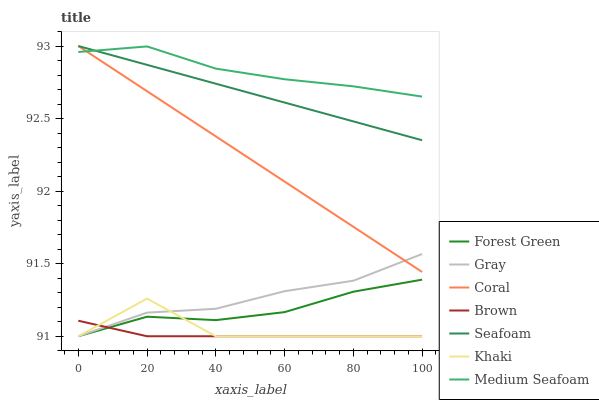Does Brown have the minimum area under the curve?
Answer yes or no. Yes. Does Medium Seafoam have the maximum area under the curve?
Answer yes or no. Yes. Does Khaki have the minimum area under the curve?
Answer yes or no. No. Does Khaki have the maximum area under the curve?
Answer yes or no. No. Is Coral the smoothest?
Answer yes or no. Yes. Is Khaki the roughest?
Answer yes or no. Yes. Is Brown the smoothest?
Answer yes or no. No. Is Brown the roughest?
Answer yes or no. No. Does Gray have the lowest value?
Answer yes or no. Yes. Does Coral have the lowest value?
Answer yes or no. No. Does Seafoam have the highest value?
Answer yes or no. Yes. Does Khaki have the highest value?
Answer yes or no. No. Is Khaki less than Seafoam?
Answer yes or no. Yes. Is Coral greater than Brown?
Answer yes or no. Yes. Does Forest Green intersect Gray?
Answer yes or no. Yes. Is Forest Green less than Gray?
Answer yes or no. No. Is Forest Green greater than Gray?
Answer yes or no. No. Does Khaki intersect Seafoam?
Answer yes or no. No. 